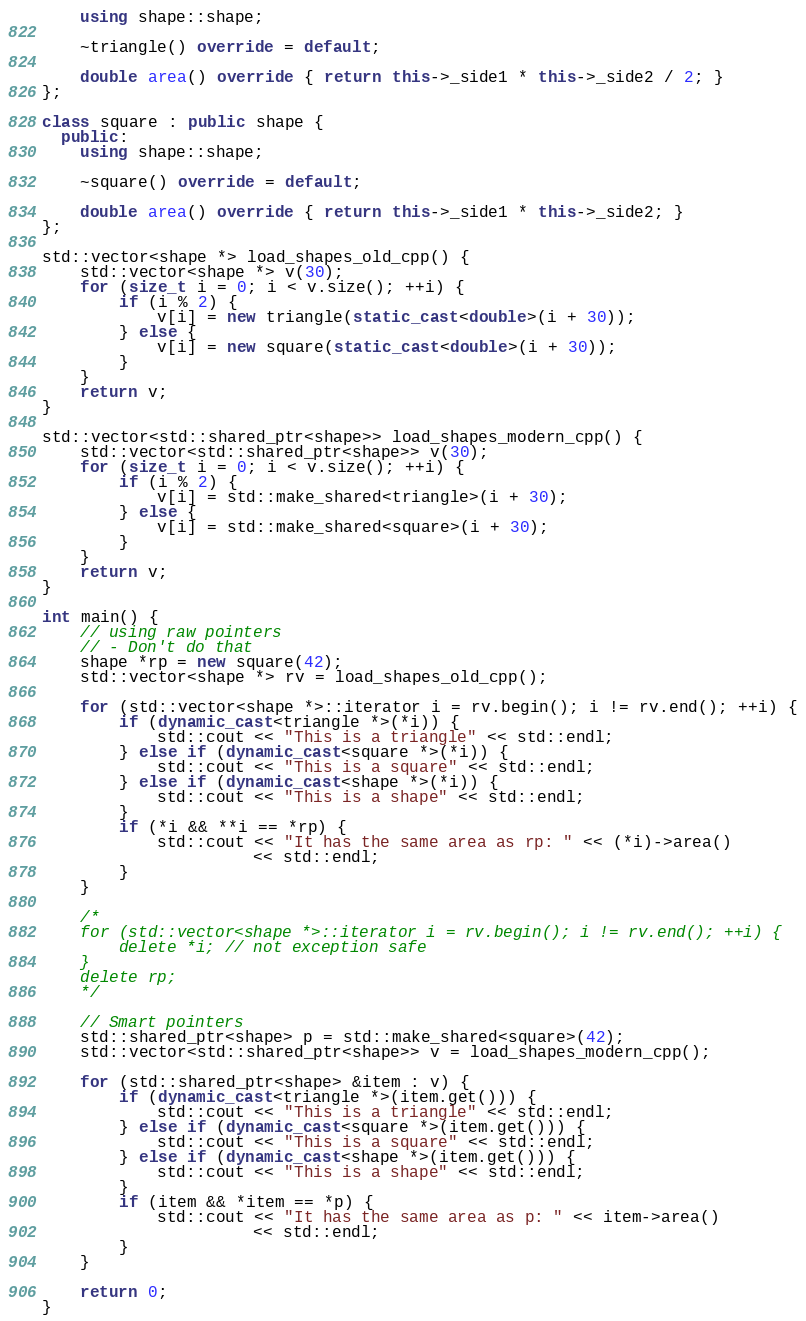<code> <loc_0><loc_0><loc_500><loc_500><_C++_>    using shape::shape;

    ~triangle() override = default;

    double area() override { return this->_side1 * this->_side2 / 2; }
};

class square : public shape {
  public:
    using shape::shape;

    ~square() override = default;

    double area() override { return this->_side1 * this->_side2; }
};

std::vector<shape *> load_shapes_old_cpp() {
    std::vector<shape *> v(30);
    for (size_t i = 0; i < v.size(); ++i) {
        if (i % 2) {
            v[i] = new triangle(static_cast<double>(i + 30));
        } else {
            v[i] = new square(static_cast<double>(i + 30));
        }
    }
    return v;
}

std::vector<std::shared_ptr<shape>> load_shapes_modern_cpp() {
    std::vector<std::shared_ptr<shape>> v(30);
    for (size_t i = 0; i < v.size(); ++i) {
        if (i % 2) {
            v[i] = std::make_shared<triangle>(i + 30);
        } else {
            v[i] = std::make_shared<square>(i + 30);
        }
    }
    return v;
}

int main() {
    // using raw pointers
    // - Don't do that
    shape *rp = new square(42);
    std::vector<shape *> rv = load_shapes_old_cpp();

    for (std::vector<shape *>::iterator i = rv.begin(); i != rv.end(); ++i) {
        if (dynamic_cast<triangle *>(*i)) {
            std::cout << "This is a triangle" << std::endl;
        } else if (dynamic_cast<square *>(*i)) {
            std::cout << "This is a square" << std::endl;
        } else if (dynamic_cast<shape *>(*i)) {
            std::cout << "This is a shape" << std::endl;
        }
        if (*i && **i == *rp) {
            std::cout << "It has the same area as rp: " << (*i)->area()
                      << std::endl;
        }
    }

    /*
    for (std::vector<shape *>::iterator i = rv.begin(); i != rv.end(); ++i) {
        delete *i; // not exception safe
    }
    delete rp;
    */

    // Smart pointers
    std::shared_ptr<shape> p = std::make_shared<square>(42);
    std::vector<std::shared_ptr<shape>> v = load_shapes_modern_cpp();

    for (std::shared_ptr<shape> &item : v) {
        if (dynamic_cast<triangle *>(item.get())) {
            std::cout << "This is a triangle" << std::endl;
        } else if (dynamic_cast<square *>(item.get())) {
            std::cout << "This is a square" << std::endl;
        } else if (dynamic_cast<shape *>(item.get())) {
            std::cout << "This is a shape" << std::endl;
        }
        if (item && *item == *p) {
            std::cout << "It has the same area as p: " << item->area()
                      << std::endl;
        }
    }

    return 0;
}</code> 